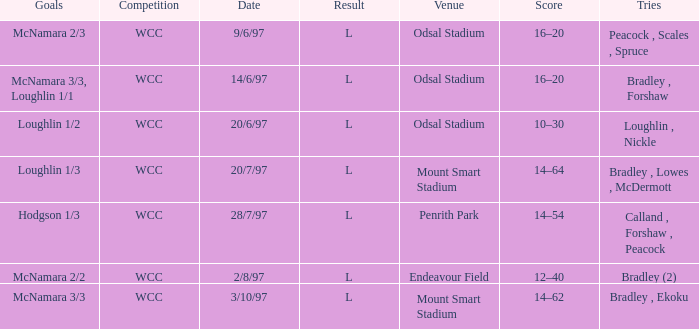What were the goals on 3/10/97? McNamara 3/3. 